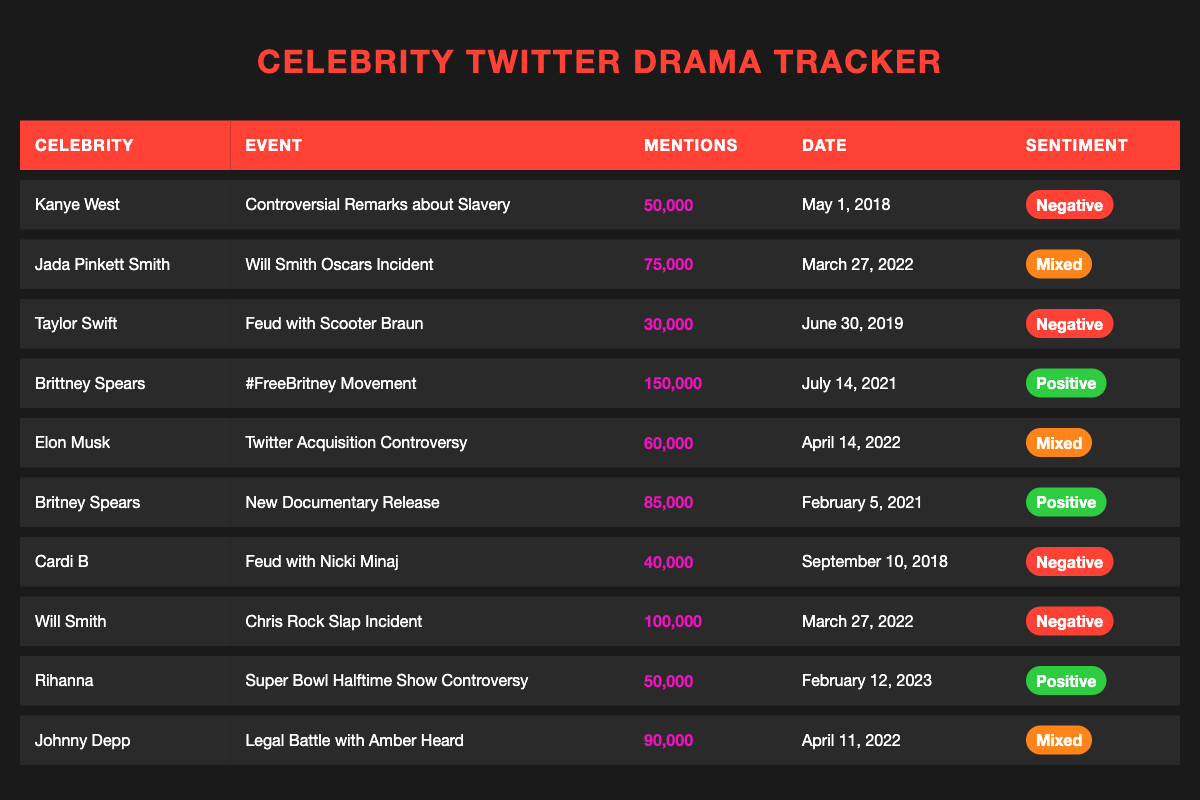What event saw the highest Twitter mentions? Looking at the table, the event with the highest Mentions Count is the "#FreeBritney Movement" with 150,000 mentions.
Answer: #FreeBritney Movement How many mentions did Will Smith receive during the Chris Rock incident? According to the table, Will Smith received 100,000 mentions during the Chris Rock Slap Incident.
Answer: 100,000 Which celebrity had a mixed sentiment during their mentioned event? From the table, Jada Pinkett Smith for the "Will Smith Oscars Incident," Elon Musk for the "Twitter Acquisition Controversy," and Johnny Depp for the "Legal Battle with Amber Heard" all have mixed sentiment.
Answer: Jada Pinkett Smith, Elon Musk, and Johnny Depp What is the total number of mentions for celebrities associated with negative sentiment? The negative mentions include: Kanye West (50,000), Taylor Swift (30,000), Cardi B (40,000), Will Smith (100,000). The total is 50,000 + 30,000 + 40,000 + 100,000 = 220,000.
Answer: 220,000 Which event occurred on March 27, 2022? The events listed for March 27, 2022, are the "Will Smith Oscars Incident" with 75,000 mentions and the "Chris Rock Slap Incident" with 100,000 mentions.
Answer: Will Smith Oscars Incident and Chris Rock Slap Incident How many more mentions did Brittney Spears receive during the #FreeBritney Movement compared to Taylor Swift’s feud with Scooter Braun? Brittney Spears received 150,000 mentions and Taylor Swift received 30,000 mentions. The difference is 150,000 - 30,000 = 120,000 mentions more.
Answer: 120,000 Is the sentiment for Britney Spears' events overall positive or negative? The events for Britney Spears show "#FreeBritney Movement" (Positive, 150,000 mentions) and "New Documentary Release" (Positive, 85,000 mentions), making the overall sentiment positive.
Answer: Positive Which celebrity had the least mentions during their controversial event? By reviewing the table, Taylor Swift received the least mentions with 30,000 during her feud with Scooter Braun.
Answer: Taylor Swift What is the average number of mentions for events with positive sentiment? The events with positive sentiment are: #FreeBritney Movement (150,000), New Documentary Release (85,000), and Super Bowl Halftime Show Controversy (50,000). The total is 150,000 + 85,000 + 50,000 = 285,000. The average is 285,000 / 3 = 95,000.
Answer: 95,000 Did any events occur in February 2023? Yes, there was an event, the "Super Bowl Halftime Show Controversy" on February 12, 2023.
Answer: Yes Which celebrity received the highest negative sentiment mentions? Will Smith during the Chris Rock incident received 100,000 mentions, making it the highest among negative sentiment mentions.
Answer: Will Smith 